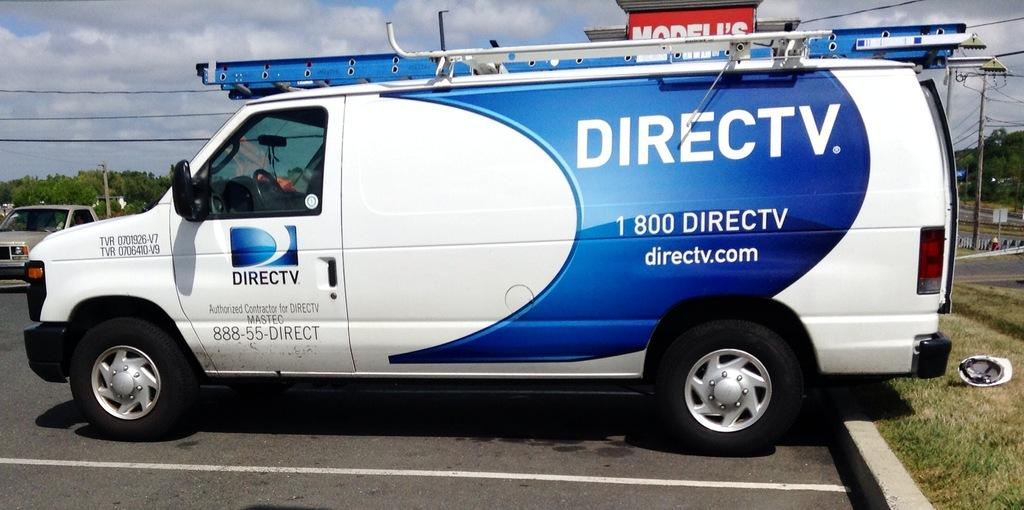<image>
Offer a succinct explanation of the picture presented. A Direct TV van is backed into a parking spot. 